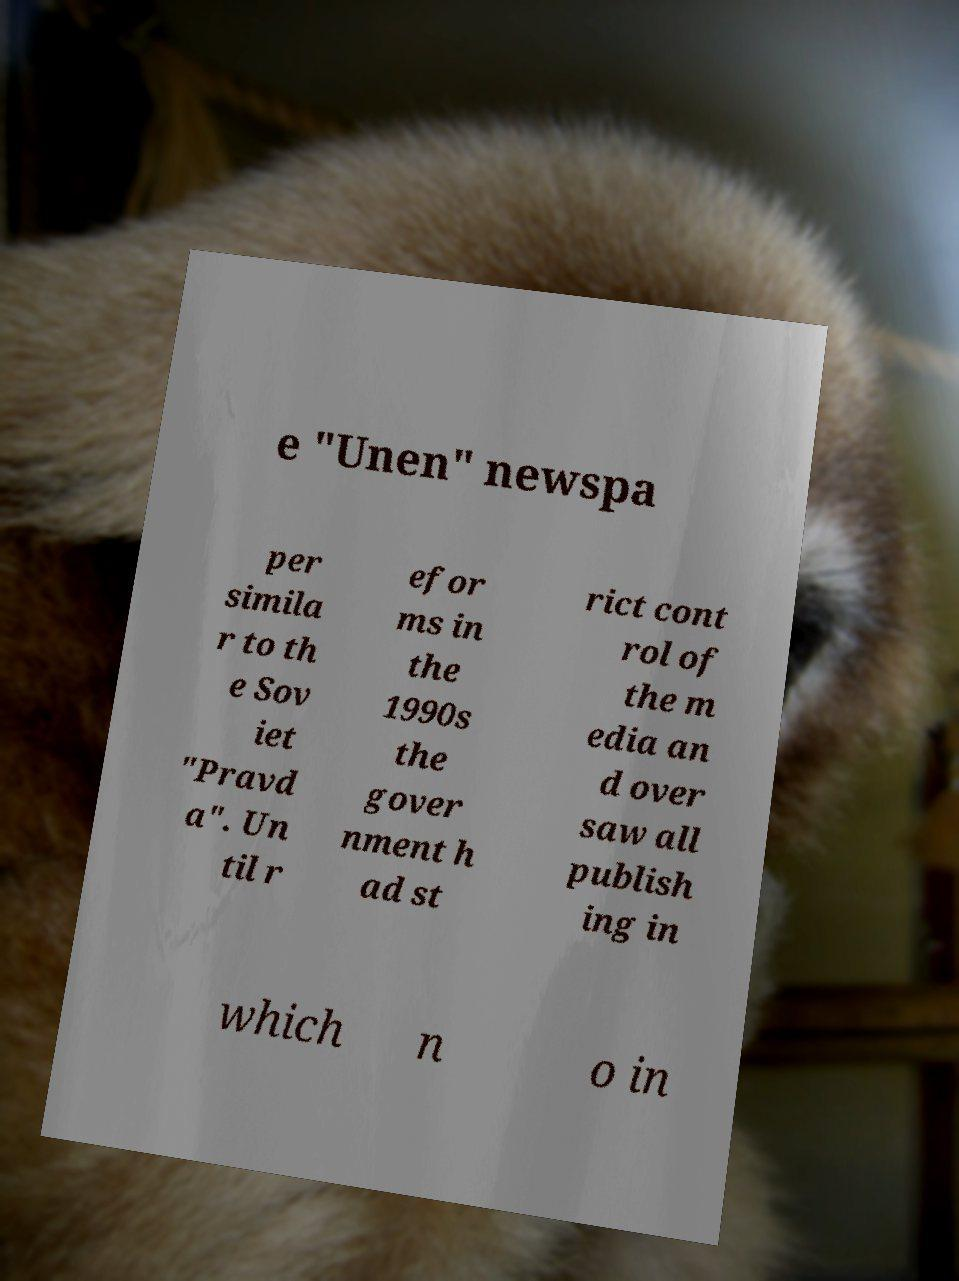Please read and relay the text visible in this image. What does it say? e "Unen" newspa per simila r to th e Sov iet "Pravd a". Un til r efor ms in the 1990s the gover nment h ad st rict cont rol of the m edia an d over saw all publish ing in which n o in 